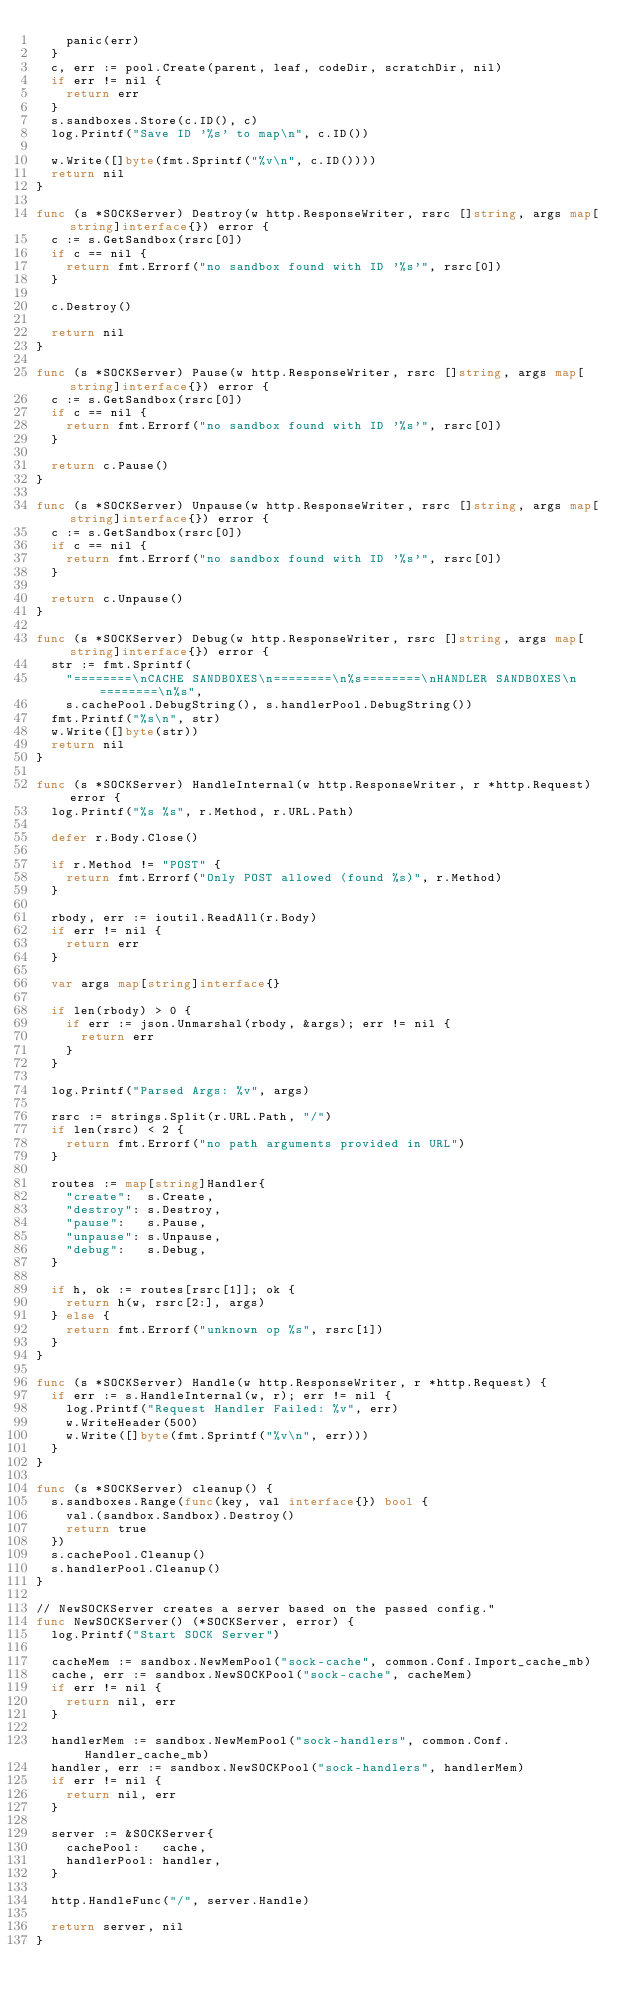Convert code to text. <code><loc_0><loc_0><loc_500><loc_500><_Go_>		panic(err)
	}
	c, err := pool.Create(parent, leaf, codeDir, scratchDir, nil)
	if err != nil {
		return err
	}
	s.sandboxes.Store(c.ID(), c)
	log.Printf("Save ID '%s' to map\n", c.ID())

	w.Write([]byte(fmt.Sprintf("%v\n", c.ID())))
	return nil
}

func (s *SOCKServer) Destroy(w http.ResponseWriter, rsrc []string, args map[string]interface{}) error {
	c := s.GetSandbox(rsrc[0])
	if c == nil {
		return fmt.Errorf("no sandbox found with ID '%s'", rsrc[0])
	}

	c.Destroy()

	return nil
}

func (s *SOCKServer) Pause(w http.ResponseWriter, rsrc []string, args map[string]interface{}) error {
	c := s.GetSandbox(rsrc[0])
	if c == nil {
		return fmt.Errorf("no sandbox found with ID '%s'", rsrc[0])
	}

	return c.Pause()
}

func (s *SOCKServer) Unpause(w http.ResponseWriter, rsrc []string, args map[string]interface{}) error {
	c := s.GetSandbox(rsrc[0])
	if c == nil {
		return fmt.Errorf("no sandbox found with ID '%s'", rsrc[0])
	}

	return c.Unpause()
}

func (s *SOCKServer) Debug(w http.ResponseWriter, rsrc []string, args map[string]interface{}) error {
	str := fmt.Sprintf(
		"========\nCACHE SANDBOXES\n========\n%s========\nHANDLER SANDBOXES\n========\n%s",
		s.cachePool.DebugString(), s.handlerPool.DebugString())
	fmt.Printf("%s\n", str)
	w.Write([]byte(str))
	return nil
}

func (s *SOCKServer) HandleInternal(w http.ResponseWriter, r *http.Request) error {
	log.Printf("%s %s", r.Method, r.URL.Path)

	defer r.Body.Close()

	if r.Method != "POST" {
		return fmt.Errorf("Only POST allowed (found %s)", r.Method)
	}

	rbody, err := ioutil.ReadAll(r.Body)
	if err != nil {
		return err
	}

	var args map[string]interface{}

	if len(rbody) > 0 {
		if err := json.Unmarshal(rbody, &args); err != nil {
			return err
		}
	}

	log.Printf("Parsed Args: %v", args)

	rsrc := strings.Split(r.URL.Path, "/")
	if len(rsrc) < 2 {
		return fmt.Errorf("no path arguments provided in URL")
	}

	routes := map[string]Handler{
		"create":  s.Create,
		"destroy": s.Destroy,
		"pause":   s.Pause,
		"unpause": s.Unpause,
		"debug":   s.Debug,
	}

	if h, ok := routes[rsrc[1]]; ok {
		return h(w, rsrc[2:], args)
	} else {
		return fmt.Errorf("unknown op %s", rsrc[1])
	}
}

func (s *SOCKServer) Handle(w http.ResponseWriter, r *http.Request) {
	if err := s.HandleInternal(w, r); err != nil {
		log.Printf("Request Handler Failed: %v", err)
		w.WriteHeader(500)
		w.Write([]byte(fmt.Sprintf("%v\n", err)))
	}
}

func (s *SOCKServer) cleanup() {
	s.sandboxes.Range(func(key, val interface{}) bool {
		val.(sandbox.Sandbox).Destroy()
		return true
	})
	s.cachePool.Cleanup()
	s.handlerPool.Cleanup()
}

// NewSOCKServer creates a server based on the passed config."
func NewSOCKServer() (*SOCKServer, error) {
	log.Printf("Start SOCK Server")

	cacheMem := sandbox.NewMemPool("sock-cache", common.Conf.Import_cache_mb)
	cache, err := sandbox.NewSOCKPool("sock-cache", cacheMem)
	if err != nil {
		return nil, err
	}

	handlerMem := sandbox.NewMemPool("sock-handlers", common.Conf.Handler_cache_mb)
	handler, err := sandbox.NewSOCKPool("sock-handlers", handlerMem)
	if err != nil {
		return nil, err
	}

	server := &SOCKServer{
		cachePool:   cache,
		handlerPool: handler,
	}

	http.HandleFunc("/", server.Handle)

	return server, nil
}
</code> 